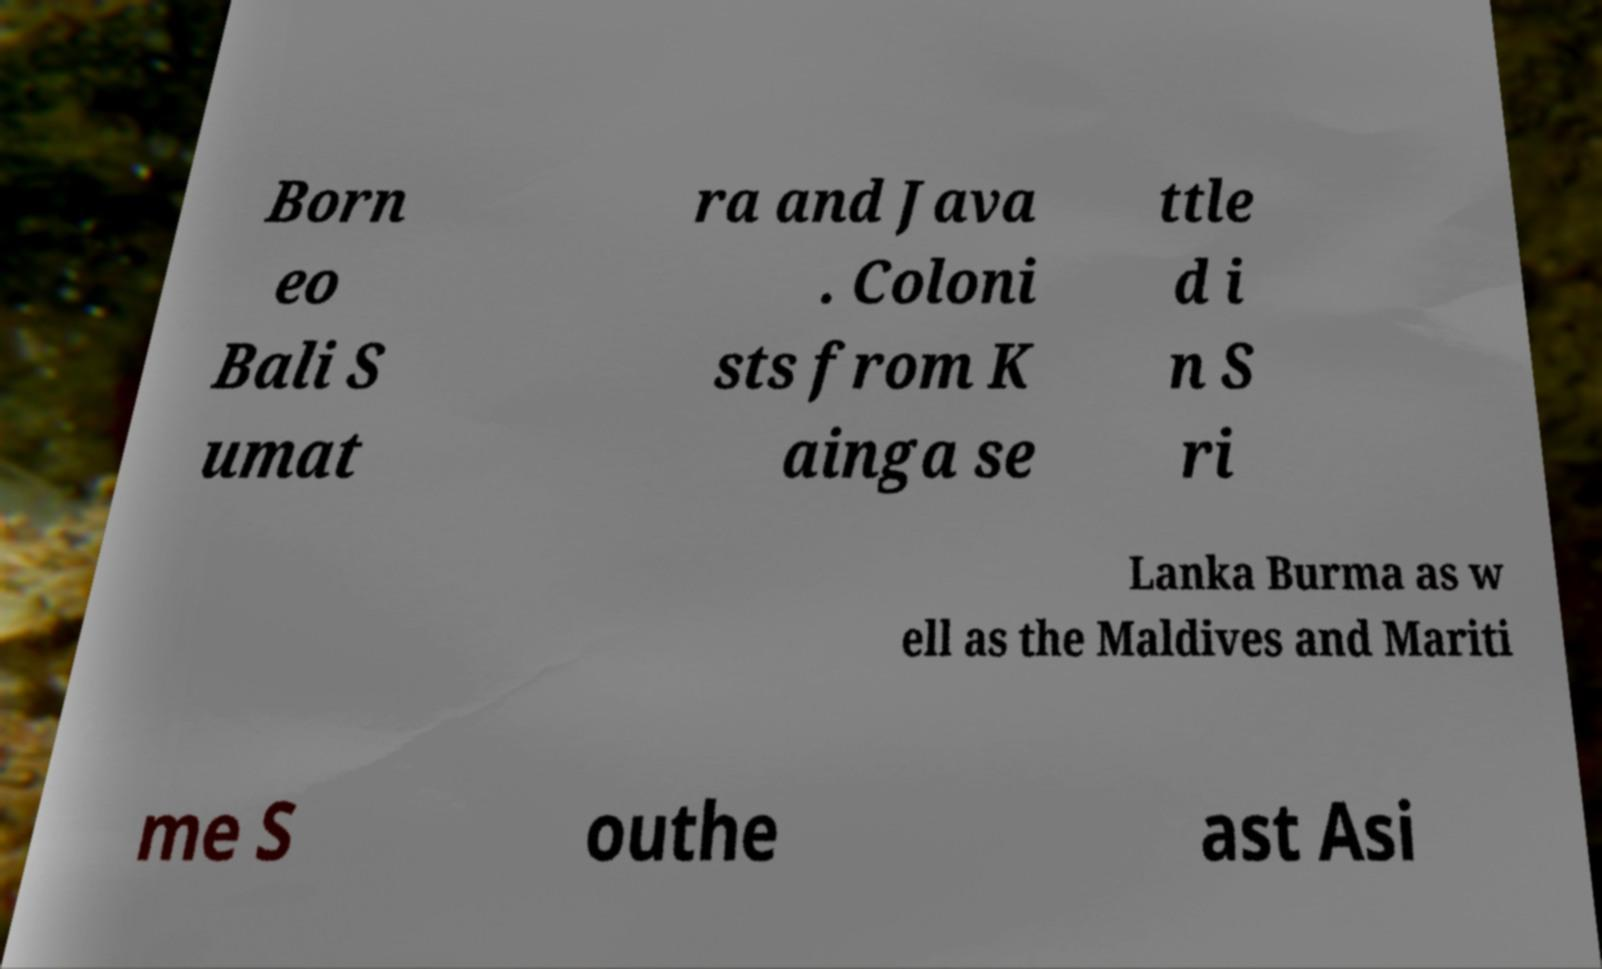Please identify and transcribe the text found in this image. Born eo Bali S umat ra and Java . Coloni sts from K ainga se ttle d i n S ri Lanka Burma as w ell as the Maldives and Mariti me S outhe ast Asi 